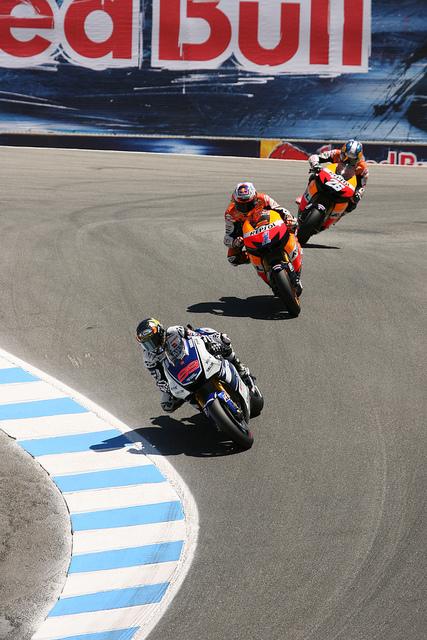What year was this taken?
Quick response, please. 2012. Who is sponsoring this event?
Write a very short answer. Red bull. Is this a motorcycle race?
Write a very short answer. Yes. How many motorcycles are there?
Concise answer only. 3. 